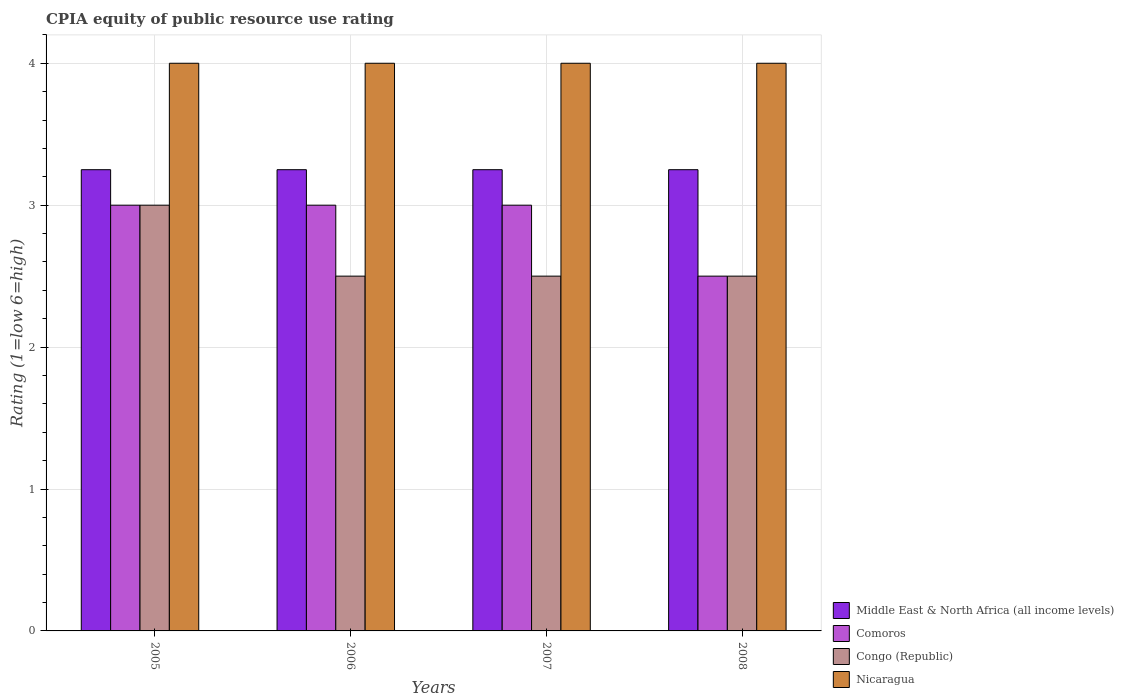Are the number of bars on each tick of the X-axis equal?
Your answer should be very brief. Yes. What is the label of the 4th group of bars from the left?
Ensure brevity in your answer.  2008. In how many cases, is the number of bars for a given year not equal to the number of legend labels?
Give a very brief answer. 0. What is the average CPIA rating in Middle East & North Africa (all income levels) per year?
Provide a succinct answer. 3.25. What is the difference between the highest and the second highest CPIA rating in Comoros?
Provide a short and direct response. 0. In how many years, is the CPIA rating in Nicaragua greater than the average CPIA rating in Nicaragua taken over all years?
Ensure brevity in your answer.  0. Is it the case that in every year, the sum of the CPIA rating in Nicaragua and CPIA rating in Comoros is greater than the sum of CPIA rating in Congo (Republic) and CPIA rating in Middle East & North Africa (all income levels)?
Your answer should be very brief. Yes. What does the 1st bar from the left in 2007 represents?
Provide a succinct answer. Middle East & North Africa (all income levels). What does the 3rd bar from the right in 2007 represents?
Offer a terse response. Comoros. How many bars are there?
Make the answer very short. 16. Are all the bars in the graph horizontal?
Provide a succinct answer. No. How many years are there in the graph?
Provide a short and direct response. 4. What is the difference between two consecutive major ticks on the Y-axis?
Your answer should be compact. 1. Does the graph contain any zero values?
Your response must be concise. No. Does the graph contain grids?
Provide a succinct answer. Yes. What is the title of the graph?
Your response must be concise. CPIA equity of public resource use rating. Does "Sri Lanka" appear as one of the legend labels in the graph?
Provide a short and direct response. No. What is the label or title of the X-axis?
Offer a very short reply. Years. What is the Rating (1=low 6=high) in Congo (Republic) in 2005?
Give a very brief answer. 3. What is the Rating (1=low 6=high) in Nicaragua in 2005?
Keep it short and to the point. 4. What is the Rating (1=low 6=high) of Nicaragua in 2006?
Make the answer very short. 4. What is the Rating (1=low 6=high) in Middle East & North Africa (all income levels) in 2007?
Keep it short and to the point. 3.25. What is the Rating (1=low 6=high) of Comoros in 2007?
Provide a succinct answer. 3. What is the Rating (1=low 6=high) in Nicaragua in 2007?
Provide a short and direct response. 4. What is the Rating (1=low 6=high) in Middle East & North Africa (all income levels) in 2008?
Ensure brevity in your answer.  3.25. What is the Rating (1=low 6=high) of Congo (Republic) in 2008?
Ensure brevity in your answer.  2.5. What is the Rating (1=low 6=high) in Nicaragua in 2008?
Provide a short and direct response. 4. Across all years, what is the maximum Rating (1=low 6=high) in Nicaragua?
Make the answer very short. 4. Across all years, what is the minimum Rating (1=low 6=high) of Middle East & North Africa (all income levels)?
Your answer should be compact. 3.25. Across all years, what is the minimum Rating (1=low 6=high) in Comoros?
Keep it short and to the point. 2.5. What is the total Rating (1=low 6=high) in Congo (Republic) in the graph?
Offer a terse response. 10.5. What is the difference between the Rating (1=low 6=high) in Middle East & North Africa (all income levels) in 2005 and that in 2006?
Offer a terse response. 0. What is the difference between the Rating (1=low 6=high) in Nicaragua in 2005 and that in 2006?
Ensure brevity in your answer.  0. What is the difference between the Rating (1=low 6=high) of Middle East & North Africa (all income levels) in 2005 and that in 2007?
Your response must be concise. 0. What is the difference between the Rating (1=low 6=high) in Comoros in 2005 and that in 2007?
Offer a very short reply. 0. What is the difference between the Rating (1=low 6=high) in Congo (Republic) in 2005 and that in 2008?
Keep it short and to the point. 0.5. What is the difference between the Rating (1=low 6=high) of Nicaragua in 2005 and that in 2008?
Offer a very short reply. 0. What is the difference between the Rating (1=low 6=high) of Middle East & North Africa (all income levels) in 2006 and that in 2007?
Provide a short and direct response. 0. What is the difference between the Rating (1=low 6=high) in Comoros in 2006 and that in 2007?
Your answer should be compact. 0. What is the difference between the Rating (1=low 6=high) in Comoros in 2006 and that in 2008?
Keep it short and to the point. 0.5. What is the difference between the Rating (1=low 6=high) of Congo (Republic) in 2006 and that in 2008?
Make the answer very short. 0. What is the difference between the Rating (1=low 6=high) in Nicaragua in 2006 and that in 2008?
Ensure brevity in your answer.  0. What is the difference between the Rating (1=low 6=high) in Middle East & North Africa (all income levels) in 2007 and that in 2008?
Your answer should be compact. 0. What is the difference between the Rating (1=low 6=high) of Comoros in 2007 and that in 2008?
Keep it short and to the point. 0.5. What is the difference between the Rating (1=low 6=high) in Congo (Republic) in 2007 and that in 2008?
Your response must be concise. 0. What is the difference between the Rating (1=low 6=high) in Middle East & North Africa (all income levels) in 2005 and the Rating (1=low 6=high) in Congo (Republic) in 2006?
Your response must be concise. 0.75. What is the difference between the Rating (1=low 6=high) in Middle East & North Africa (all income levels) in 2005 and the Rating (1=low 6=high) in Nicaragua in 2006?
Your answer should be compact. -0.75. What is the difference between the Rating (1=low 6=high) of Congo (Republic) in 2005 and the Rating (1=low 6=high) of Nicaragua in 2006?
Offer a terse response. -1. What is the difference between the Rating (1=low 6=high) in Middle East & North Africa (all income levels) in 2005 and the Rating (1=low 6=high) in Congo (Republic) in 2007?
Offer a very short reply. 0.75. What is the difference between the Rating (1=low 6=high) of Middle East & North Africa (all income levels) in 2005 and the Rating (1=low 6=high) of Nicaragua in 2007?
Provide a short and direct response. -0.75. What is the difference between the Rating (1=low 6=high) of Comoros in 2005 and the Rating (1=low 6=high) of Nicaragua in 2007?
Ensure brevity in your answer.  -1. What is the difference between the Rating (1=low 6=high) of Congo (Republic) in 2005 and the Rating (1=low 6=high) of Nicaragua in 2007?
Provide a succinct answer. -1. What is the difference between the Rating (1=low 6=high) of Middle East & North Africa (all income levels) in 2005 and the Rating (1=low 6=high) of Nicaragua in 2008?
Make the answer very short. -0.75. What is the difference between the Rating (1=low 6=high) in Comoros in 2005 and the Rating (1=low 6=high) in Congo (Republic) in 2008?
Offer a very short reply. 0.5. What is the difference between the Rating (1=low 6=high) in Comoros in 2005 and the Rating (1=low 6=high) in Nicaragua in 2008?
Offer a terse response. -1. What is the difference between the Rating (1=low 6=high) of Congo (Republic) in 2005 and the Rating (1=low 6=high) of Nicaragua in 2008?
Your answer should be compact. -1. What is the difference between the Rating (1=low 6=high) of Middle East & North Africa (all income levels) in 2006 and the Rating (1=low 6=high) of Comoros in 2007?
Your answer should be very brief. 0.25. What is the difference between the Rating (1=low 6=high) of Middle East & North Africa (all income levels) in 2006 and the Rating (1=low 6=high) of Nicaragua in 2007?
Offer a very short reply. -0.75. What is the difference between the Rating (1=low 6=high) of Comoros in 2006 and the Rating (1=low 6=high) of Congo (Republic) in 2007?
Make the answer very short. 0.5. What is the difference between the Rating (1=low 6=high) in Comoros in 2006 and the Rating (1=low 6=high) in Nicaragua in 2007?
Your response must be concise. -1. What is the difference between the Rating (1=low 6=high) of Congo (Republic) in 2006 and the Rating (1=low 6=high) of Nicaragua in 2007?
Give a very brief answer. -1.5. What is the difference between the Rating (1=low 6=high) in Middle East & North Africa (all income levels) in 2006 and the Rating (1=low 6=high) in Congo (Republic) in 2008?
Give a very brief answer. 0.75. What is the difference between the Rating (1=low 6=high) of Middle East & North Africa (all income levels) in 2006 and the Rating (1=low 6=high) of Nicaragua in 2008?
Keep it short and to the point. -0.75. What is the difference between the Rating (1=low 6=high) in Comoros in 2006 and the Rating (1=low 6=high) in Congo (Republic) in 2008?
Your response must be concise. 0.5. What is the difference between the Rating (1=low 6=high) of Comoros in 2006 and the Rating (1=low 6=high) of Nicaragua in 2008?
Offer a very short reply. -1. What is the difference between the Rating (1=low 6=high) of Middle East & North Africa (all income levels) in 2007 and the Rating (1=low 6=high) of Congo (Republic) in 2008?
Provide a succinct answer. 0.75. What is the difference between the Rating (1=low 6=high) of Middle East & North Africa (all income levels) in 2007 and the Rating (1=low 6=high) of Nicaragua in 2008?
Ensure brevity in your answer.  -0.75. What is the difference between the Rating (1=low 6=high) in Comoros in 2007 and the Rating (1=low 6=high) in Congo (Republic) in 2008?
Provide a succinct answer. 0.5. What is the difference between the Rating (1=low 6=high) in Comoros in 2007 and the Rating (1=low 6=high) in Nicaragua in 2008?
Your answer should be compact. -1. What is the average Rating (1=low 6=high) of Comoros per year?
Offer a terse response. 2.88. What is the average Rating (1=low 6=high) of Congo (Republic) per year?
Ensure brevity in your answer.  2.62. What is the average Rating (1=low 6=high) of Nicaragua per year?
Provide a succinct answer. 4. In the year 2005, what is the difference between the Rating (1=low 6=high) in Middle East & North Africa (all income levels) and Rating (1=low 6=high) in Comoros?
Keep it short and to the point. 0.25. In the year 2005, what is the difference between the Rating (1=low 6=high) of Middle East & North Africa (all income levels) and Rating (1=low 6=high) of Nicaragua?
Give a very brief answer. -0.75. In the year 2005, what is the difference between the Rating (1=low 6=high) of Comoros and Rating (1=low 6=high) of Congo (Republic)?
Make the answer very short. 0. In the year 2005, what is the difference between the Rating (1=low 6=high) in Comoros and Rating (1=low 6=high) in Nicaragua?
Provide a succinct answer. -1. In the year 2005, what is the difference between the Rating (1=low 6=high) of Congo (Republic) and Rating (1=low 6=high) of Nicaragua?
Your answer should be compact. -1. In the year 2006, what is the difference between the Rating (1=low 6=high) in Middle East & North Africa (all income levels) and Rating (1=low 6=high) in Nicaragua?
Offer a terse response. -0.75. In the year 2006, what is the difference between the Rating (1=low 6=high) in Comoros and Rating (1=low 6=high) in Congo (Republic)?
Provide a short and direct response. 0.5. In the year 2006, what is the difference between the Rating (1=low 6=high) in Congo (Republic) and Rating (1=low 6=high) in Nicaragua?
Offer a terse response. -1.5. In the year 2007, what is the difference between the Rating (1=low 6=high) of Middle East & North Africa (all income levels) and Rating (1=low 6=high) of Congo (Republic)?
Keep it short and to the point. 0.75. In the year 2007, what is the difference between the Rating (1=low 6=high) in Middle East & North Africa (all income levels) and Rating (1=low 6=high) in Nicaragua?
Offer a terse response. -0.75. In the year 2007, what is the difference between the Rating (1=low 6=high) in Comoros and Rating (1=low 6=high) in Congo (Republic)?
Offer a very short reply. 0.5. In the year 2007, what is the difference between the Rating (1=low 6=high) of Comoros and Rating (1=low 6=high) of Nicaragua?
Offer a terse response. -1. In the year 2008, what is the difference between the Rating (1=low 6=high) of Middle East & North Africa (all income levels) and Rating (1=low 6=high) of Nicaragua?
Your response must be concise. -0.75. In the year 2008, what is the difference between the Rating (1=low 6=high) of Comoros and Rating (1=low 6=high) of Nicaragua?
Offer a very short reply. -1.5. What is the ratio of the Rating (1=low 6=high) of Congo (Republic) in 2005 to that in 2006?
Give a very brief answer. 1.2. What is the ratio of the Rating (1=low 6=high) in Nicaragua in 2005 to that in 2006?
Offer a terse response. 1. What is the ratio of the Rating (1=low 6=high) of Nicaragua in 2005 to that in 2007?
Offer a very short reply. 1. What is the ratio of the Rating (1=low 6=high) of Congo (Republic) in 2005 to that in 2008?
Offer a terse response. 1.2. What is the ratio of the Rating (1=low 6=high) of Middle East & North Africa (all income levels) in 2006 to that in 2007?
Make the answer very short. 1. What is the ratio of the Rating (1=low 6=high) in Congo (Republic) in 2006 to that in 2007?
Offer a terse response. 1. What is the ratio of the Rating (1=low 6=high) of Middle East & North Africa (all income levels) in 2006 to that in 2008?
Your answer should be compact. 1. What is the ratio of the Rating (1=low 6=high) in Congo (Republic) in 2006 to that in 2008?
Provide a short and direct response. 1. What is the ratio of the Rating (1=low 6=high) of Nicaragua in 2006 to that in 2008?
Provide a succinct answer. 1. What is the ratio of the Rating (1=low 6=high) in Comoros in 2007 to that in 2008?
Make the answer very short. 1.2. What is the difference between the highest and the second highest Rating (1=low 6=high) of Congo (Republic)?
Provide a short and direct response. 0.5. 